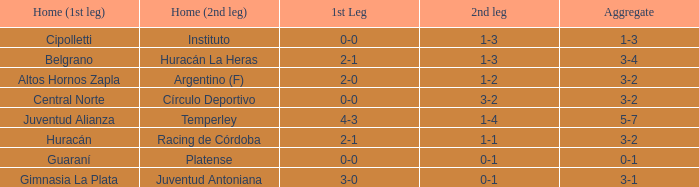Who played at home for the second leg with a score of 0-1 and tied 0-0 in the first leg? Platense. 